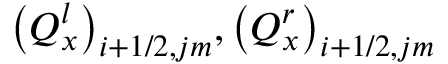Convert formula to latex. <formula><loc_0><loc_0><loc_500><loc_500>{ { \left ( Q _ { x } ^ { l } \right ) } _ { i + 1 / 2 , j m } } , { { \left ( Q _ { x } ^ { r } \right ) } _ { i + 1 / 2 , j m } }</formula> 